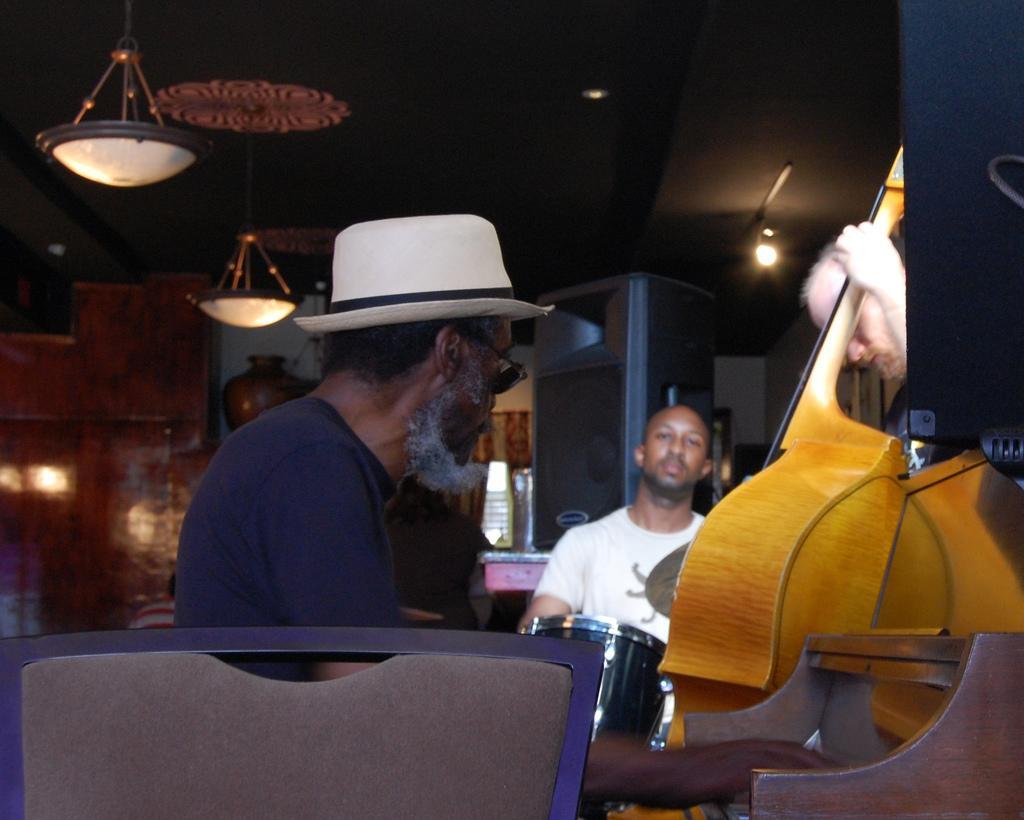How would you summarize this image in a sentence or two? At the bottom, we see a chair. Behind that, we see a man in the black T-shirt who is wearing a white hat is sitting on the chair. He is playing the musical instrument. On the right side, we see a black color object. Beside that, we see a man is standing and he is holding the musical instrument. In the middle, we see a man in the white T-shirt is playing the drums. In the background, we see a cupboard, window and a wall in white and brown color. At the top, we see the lights, lanterns and the ceiling of the room. 